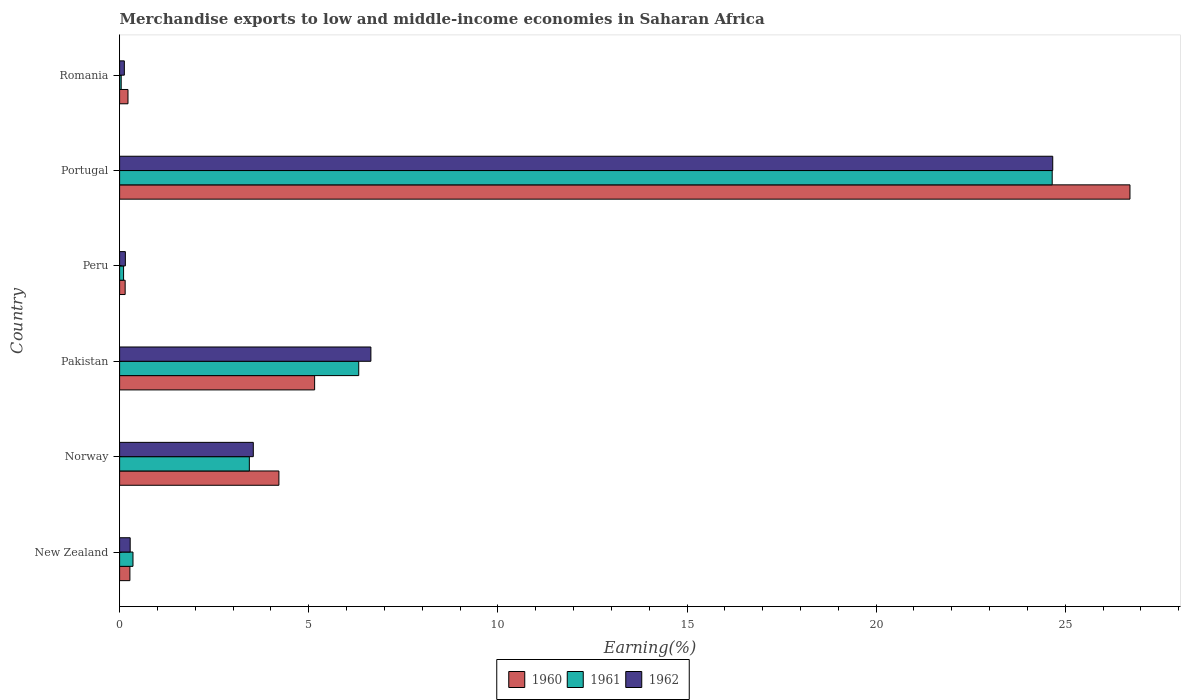How many different coloured bars are there?
Make the answer very short. 3. How many groups of bars are there?
Your answer should be very brief. 6. Are the number of bars per tick equal to the number of legend labels?
Ensure brevity in your answer.  Yes. Are the number of bars on each tick of the Y-axis equal?
Ensure brevity in your answer.  Yes. How many bars are there on the 5th tick from the bottom?
Offer a very short reply. 3. In how many cases, is the number of bars for a given country not equal to the number of legend labels?
Your answer should be very brief. 0. What is the percentage of amount earned from merchandise exports in 1961 in Romania?
Your response must be concise. 0.04. Across all countries, what is the maximum percentage of amount earned from merchandise exports in 1960?
Offer a very short reply. 26.71. Across all countries, what is the minimum percentage of amount earned from merchandise exports in 1960?
Offer a terse response. 0.15. In which country was the percentage of amount earned from merchandise exports in 1960 maximum?
Offer a very short reply. Portugal. In which country was the percentage of amount earned from merchandise exports in 1962 minimum?
Offer a very short reply. Romania. What is the total percentage of amount earned from merchandise exports in 1961 in the graph?
Your response must be concise. 34.91. What is the difference between the percentage of amount earned from merchandise exports in 1962 in Portugal and that in Romania?
Offer a terse response. 24.54. What is the difference between the percentage of amount earned from merchandise exports in 1960 in Peru and the percentage of amount earned from merchandise exports in 1962 in Norway?
Offer a terse response. -3.39. What is the average percentage of amount earned from merchandise exports in 1960 per country?
Your answer should be compact. 6.12. What is the difference between the percentage of amount earned from merchandise exports in 1961 and percentage of amount earned from merchandise exports in 1962 in Peru?
Your response must be concise. -0.05. In how many countries, is the percentage of amount earned from merchandise exports in 1960 greater than 23 %?
Provide a succinct answer. 1. What is the ratio of the percentage of amount earned from merchandise exports in 1960 in New Zealand to that in Portugal?
Make the answer very short. 0.01. Is the percentage of amount earned from merchandise exports in 1960 in New Zealand less than that in Romania?
Your response must be concise. No. What is the difference between the highest and the second highest percentage of amount earned from merchandise exports in 1961?
Make the answer very short. 18.33. What is the difference between the highest and the lowest percentage of amount earned from merchandise exports in 1962?
Ensure brevity in your answer.  24.54. In how many countries, is the percentage of amount earned from merchandise exports in 1961 greater than the average percentage of amount earned from merchandise exports in 1961 taken over all countries?
Your answer should be compact. 2. What does the 3rd bar from the top in Norway represents?
Provide a succinct answer. 1960. Is it the case that in every country, the sum of the percentage of amount earned from merchandise exports in 1962 and percentage of amount earned from merchandise exports in 1960 is greater than the percentage of amount earned from merchandise exports in 1961?
Offer a terse response. Yes. How many bars are there?
Your answer should be very brief. 18. How many countries are there in the graph?
Your response must be concise. 6. Are the values on the major ticks of X-axis written in scientific E-notation?
Keep it short and to the point. No. Does the graph contain grids?
Your response must be concise. No. How many legend labels are there?
Offer a terse response. 3. What is the title of the graph?
Keep it short and to the point. Merchandise exports to low and middle-income economies in Saharan Africa. What is the label or title of the X-axis?
Make the answer very short. Earning(%). What is the label or title of the Y-axis?
Your answer should be very brief. Country. What is the Earning(%) in 1960 in New Zealand?
Provide a succinct answer. 0.27. What is the Earning(%) in 1961 in New Zealand?
Provide a short and direct response. 0.35. What is the Earning(%) of 1962 in New Zealand?
Your answer should be very brief. 0.28. What is the Earning(%) of 1960 in Norway?
Provide a short and direct response. 4.21. What is the Earning(%) in 1961 in Norway?
Keep it short and to the point. 3.43. What is the Earning(%) of 1962 in Norway?
Ensure brevity in your answer.  3.53. What is the Earning(%) in 1960 in Pakistan?
Ensure brevity in your answer.  5.16. What is the Earning(%) of 1961 in Pakistan?
Offer a very short reply. 6.32. What is the Earning(%) of 1962 in Pakistan?
Provide a short and direct response. 6.64. What is the Earning(%) in 1960 in Peru?
Your answer should be compact. 0.15. What is the Earning(%) in 1961 in Peru?
Keep it short and to the point. 0.1. What is the Earning(%) of 1962 in Peru?
Your answer should be very brief. 0.15. What is the Earning(%) in 1960 in Portugal?
Keep it short and to the point. 26.71. What is the Earning(%) of 1961 in Portugal?
Offer a terse response. 24.65. What is the Earning(%) of 1962 in Portugal?
Offer a terse response. 24.67. What is the Earning(%) of 1960 in Romania?
Offer a terse response. 0.22. What is the Earning(%) in 1961 in Romania?
Your answer should be compact. 0.04. What is the Earning(%) in 1962 in Romania?
Keep it short and to the point. 0.13. Across all countries, what is the maximum Earning(%) of 1960?
Your answer should be compact. 26.71. Across all countries, what is the maximum Earning(%) of 1961?
Offer a very short reply. 24.65. Across all countries, what is the maximum Earning(%) in 1962?
Offer a very short reply. 24.67. Across all countries, what is the minimum Earning(%) of 1960?
Your answer should be compact. 0.15. Across all countries, what is the minimum Earning(%) in 1961?
Give a very brief answer. 0.04. Across all countries, what is the minimum Earning(%) in 1962?
Keep it short and to the point. 0.13. What is the total Earning(%) in 1960 in the graph?
Ensure brevity in your answer.  36.72. What is the total Earning(%) of 1961 in the graph?
Offer a terse response. 34.91. What is the total Earning(%) of 1962 in the graph?
Offer a terse response. 35.4. What is the difference between the Earning(%) of 1960 in New Zealand and that in Norway?
Give a very brief answer. -3.94. What is the difference between the Earning(%) in 1961 in New Zealand and that in Norway?
Provide a short and direct response. -3.08. What is the difference between the Earning(%) of 1962 in New Zealand and that in Norway?
Ensure brevity in your answer.  -3.25. What is the difference between the Earning(%) in 1960 in New Zealand and that in Pakistan?
Offer a terse response. -4.88. What is the difference between the Earning(%) of 1961 in New Zealand and that in Pakistan?
Offer a terse response. -5.97. What is the difference between the Earning(%) of 1962 in New Zealand and that in Pakistan?
Offer a terse response. -6.36. What is the difference between the Earning(%) of 1960 in New Zealand and that in Peru?
Your answer should be compact. 0.13. What is the difference between the Earning(%) in 1961 in New Zealand and that in Peru?
Make the answer very short. 0.25. What is the difference between the Earning(%) of 1962 in New Zealand and that in Peru?
Ensure brevity in your answer.  0.13. What is the difference between the Earning(%) in 1960 in New Zealand and that in Portugal?
Ensure brevity in your answer.  -26.44. What is the difference between the Earning(%) of 1961 in New Zealand and that in Portugal?
Your answer should be very brief. -24.3. What is the difference between the Earning(%) of 1962 in New Zealand and that in Portugal?
Your answer should be very brief. -24.39. What is the difference between the Earning(%) of 1960 in New Zealand and that in Romania?
Provide a succinct answer. 0.05. What is the difference between the Earning(%) in 1961 in New Zealand and that in Romania?
Your answer should be very brief. 0.31. What is the difference between the Earning(%) of 1962 in New Zealand and that in Romania?
Provide a succinct answer. 0.15. What is the difference between the Earning(%) in 1960 in Norway and that in Pakistan?
Ensure brevity in your answer.  -0.94. What is the difference between the Earning(%) in 1961 in Norway and that in Pakistan?
Make the answer very short. -2.89. What is the difference between the Earning(%) of 1962 in Norway and that in Pakistan?
Your response must be concise. -3.11. What is the difference between the Earning(%) in 1960 in Norway and that in Peru?
Make the answer very short. 4.06. What is the difference between the Earning(%) in 1961 in Norway and that in Peru?
Provide a succinct answer. 3.32. What is the difference between the Earning(%) in 1962 in Norway and that in Peru?
Your answer should be compact. 3.38. What is the difference between the Earning(%) of 1960 in Norway and that in Portugal?
Ensure brevity in your answer.  -22.5. What is the difference between the Earning(%) in 1961 in Norway and that in Portugal?
Ensure brevity in your answer.  -21.22. What is the difference between the Earning(%) in 1962 in Norway and that in Portugal?
Your response must be concise. -21.13. What is the difference between the Earning(%) in 1960 in Norway and that in Romania?
Ensure brevity in your answer.  3.99. What is the difference between the Earning(%) in 1961 in Norway and that in Romania?
Offer a terse response. 3.39. What is the difference between the Earning(%) of 1962 in Norway and that in Romania?
Ensure brevity in your answer.  3.41. What is the difference between the Earning(%) in 1960 in Pakistan and that in Peru?
Keep it short and to the point. 5.01. What is the difference between the Earning(%) of 1961 in Pakistan and that in Peru?
Provide a succinct answer. 6.22. What is the difference between the Earning(%) of 1962 in Pakistan and that in Peru?
Your response must be concise. 6.49. What is the difference between the Earning(%) in 1960 in Pakistan and that in Portugal?
Ensure brevity in your answer.  -21.55. What is the difference between the Earning(%) in 1961 in Pakistan and that in Portugal?
Your answer should be compact. -18.33. What is the difference between the Earning(%) of 1962 in Pakistan and that in Portugal?
Offer a terse response. -18.03. What is the difference between the Earning(%) in 1960 in Pakistan and that in Romania?
Your response must be concise. 4.93. What is the difference between the Earning(%) of 1961 in Pakistan and that in Romania?
Provide a short and direct response. 6.28. What is the difference between the Earning(%) of 1962 in Pakistan and that in Romania?
Your answer should be compact. 6.52. What is the difference between the Earning(%) of 1960 in Peru and that in Portugal?
Offer a terse response. -26.56. What is the difference between the Earning(%) in 1961 in Peru and that in Portugal?
Provide a succinct answer. -24.55. What is the difference between the Earning(%) in 1962 in Peru and that in Portugal?
Provide a succinct answer. -24.52. What is the difference between the Earning(%) in 1960 in Peru and that in Romania?
Provide a short and direct response. -0.07. What is the difference between the Earning(%) of 1961 in Peru and that in Romania?
Offer a very short reply. 0.06. What is the difference between the Earning(%) of 1962 in Peru and that in Romania?
Offer a very short reply. 0.03. What is the difference between the Earning(%) in 1960 in Portugal and that in Romania?
Your answer should be compact. 26.49. What is the difference between the Earning(%) in 1961 in Portugal and that in Romania?
Keep it short and to the point. 24.61. What is the difference between the Earning(%) of 1962 in Portugal and that in Romania?
Offer a very short reply. 24.54. What is the difference between the Earning(%) in 1960 in New Zealand and the Earning(%) in 1961 in Norway?
Offer a terse response. -3.16. What is the difference between the Earning(%) in 1960 in New Zealand and the Earning(%) in 1962 in Norway?
Your answer should be very brief. -3.26. What is the difference between the Earning(%) in 1961 in New Zealand and the Earning(%) in 1962 in Norway?
Provide a short and direct response. -3.18. What is the difference between the Earning(%) in 1960 in New Zealand and the Earning(%) in 1961 in Pakistan?
Offer a terse response. -6.05. What is the difference between the Earning(%) of 1960 in New Zealand and the Earning(%) of 1962 in Pakistan?
Provide a succinct answer. -6.37. What is the difference between the Earning(%) of 1961 in New Zealand and the Earning(%) of 1962 in Pakistan?
Give a very brief answer. -6.29. What is the difference between the Earning(%) in 1960 in New Zealand and the Earning(%) in 1961 in Peru?
Your response must be concise. 0.17. What is the difference between the Earning(%) in 1960 in New Zealand and the Earning(%) in 1962 in Peru?
Ensure brevity in your answer.  0.12. What is the difference between the Earning(%) in 1961 in New Zealand and the Earning(%) in 1962 in Peru?
Your response must be concise. 0.2. What is the difference between the Earning(%) in 1960 in New Zealand and the Earning(%) in 1961 in Portugal?
Your answer should be compact. -24.38. What is the difference between the Earning(%) in 1960 in New Zealand and the Earning(%) in 1962 in Portugal?
Offer a terse response. -24.4. What is the difference between the Earning(%) in 1961 in New Zealand and the Earning(%) in 1962 in Portugal?
Your answer should be very brief. -24.31. What is the difference between the Earning(%) of 1960 in New Zealand and the Earning(%) of 1961 in Romania?
Provide a succinct answer. 0.23. What is the difference between the Earning(%) in 1960 in New Zealand and the Earning(%) in 1962 in Romania?
Offer a very short reply. 0.15. What is the difference between the Earning(%) of 1961 in New Zealand and the Earning(%) of 1962 in Romania?
Provide a succinct answer. 0.23. What is the difference between the Earning(%) in 1960 in Norway and the Earning(%) in 1961 in Pakistan?
Offer a very short reply. -2.11. What is the difference between the Earning(%) in 1960 in Norway and the Earning(%) in 1962 in Pakistan?
Offer a very short reply. -2.43. What is the difference between the Earning(%) in 1961 in Norway and the Earning(%) in 1962 in Pakistan?
Ensure brevity in your answer.  -3.21. What is the difference between the Earning(%) in 1960 in Norway and the Earning(%) in 1961 in Peru?
Offer a very short reply. 4.11. What is the difference between the Earning(%) of 1960 in Norway and the Earning(%) of 1962 in Peru?
Your answer should be very brief. 4.06. What is the difference between the Earning(%) in 1961 in Norway and the Earning(%) in 1962 in Peru?
Your answer should be very brief. 3.28. What is the difference between the Earning(%) of 1960 in Norway and the Earning(%) of 1961 in Portugal?
Ensure brevity in your answer.  -20.44. What is the difference between the Earning(%) of 1960 in Norway and the Earning(%) of 1962 in Portugal?
Make the answer very short. -20.46. What is the difference between the Earning(%) in 1961 in Norway and the Earning(%) in 1962 in Portugal?
Keep it short and to the point. -21.24. What is the difference between the Earning(%) of 1960 in Norway and the Earning(%) of 1961 in Romania?
Give a very brief answer. 4.17. What is the difference between the Earning(%) of 1960 in Norway and the Earning(%) of 1962 in Romania?
Your response must be concise. 4.09. What is the difference between the Earning(%) of 1961 in Norway and the Earning(%) of 1962 in Romania?
Make the answer very short. 3.3. What is the difference between the Earning(%) in 1960 in Pakistan and the Earning(%) in 1961 in Peru?
Give a very brief answer. 5.05. What is the difference between the Earning(%) in 1960 in Pakistan and the Earning(%) in 1962 in Peru?
Provide a succinct answer. 5. What is the difference between the Earning(%) of 1961 in Pakistan and the Earning(%) of 1962 in Peru?
Offer a very short reply. 6.17. What is the difference between the Earning(%) in 1960 in Pakistan and the Earning(%) in 1961 in Portugal?
Your answer should be compact. -19.5. What is the difference between the Earning(%) of 1960 in Pakistan and the Earning(%) of 1962 in Portugal?
Your answer should be compact. -19.51. What is the difference between the Earning(%) of 1961 in Pakistan and the Earning(%) of 1962 in Portugal?
Keep it short and to the point. -18.35. What is the difference between the Earning(%) in 1960 in Pakistan and the Earning(%) in 1961 in Romania?
Offer a very short reply. 5.11. What is the difference between the Earning(%) in 1960 in Pakistan and the Earning(%) in 1962 in Romania?
Offer a very short reply. 5.03. What is the difference between the Earning(%) of 1961 in Pakistan and the Earning(%) of 1962 in Romania?
Make the answer very short. 6.2. What is the difference between the Earning(%) in 1960 in Peru and the Earning(%) in 1961 in Portugal?
Give a very brief answer. -24.51. What is the difference between the Earning(%) in 1960 in Peru and the Earning(%) in 1962 in Portugal?
Give a very brief answer. -24.52. What is the difference between the Earning(%) in 1961 in Peru and the Earning(%) in 1962 in Portugal?
Offer a very short reply. -24.56. What is the difference between the Earning(%) in 1960 in Peru and the Earning(%) in 1961 in Romania?
Provide a succinct answer. 0.1. What is the difference between the Earning(%) in 1960 in Peru and the Earning(%) in 1962 in Romania?
Make the answer very short. 0.02. What is the difference between the Earning(%) in 1961 in Peru and the Earning(%) in 1962 in Romania?
Offer a terse response. -0.02. What is the difference between the Earning(%) in 1960 in Portugal and the Earning(%) in 1961 in Romania?
Ensure brevity in your answer.  26.67. What is the difference between the Earning(%) of 1960 in Portugal and the Earning(%) of 1962 in Romania?
Make the answer very short. 26.58. What is the difference between the Earning(%) in 1961 in Portugal and the Earning(%) in 1962 in Romania?
Provide a short and direct response. 24.53. What is the average Earning(%) of 1960 per country?
Offer a very short reply. 6.12. What is the average Earning(%) of 1961 per country?
Offer a very short reply. 5.82. What is the average Earning(%) of 1962 per country?
Provide a succinct answer. 5.9. What is the difference between the Earning(%) of 1960 and Earning(%) of 1961 in New Zealand?
Keep it short and to the point. -0.08. What is the difference between the Earning(%) in 1960 and Earning(%) in 1962 in New Zealand?
Give a very brief answer. -0.01. What is the difference between the Earning(%) of 1961 and Earning(%) of 1962 in New Zealand?
Ensure brevity in your answer.  0.07. What is the difference between the Earning(%) in 1960 and Earning(%) in 1961 in Norway?
Provide a succinct answer. 0.78. What is the difference between the Earning(%) of 1960 and Earning(%) of 1962 in Norway?
Give a very brief answer. 0.68. What is the difference between the Earning(%) of 1961 and Earning(%) of 1962 in Norway?
Make the answer very short. -0.1. What is the difference between the Earning(%) of 1960 and Earning(%) of 1961 in Pakistan?
Keep it short and to the point. -1.17. What is the difference between the Earning(%) in 1960 and Earning(%) in 1962 in Pakistan?
Ensure brevity in your answer.  -1.49. What is the difference between the Earning(%) in 1961 and Earning(%) in 1962 in Pakistan?
Make the answer very short. -0.32. What is the difference between the Earning(%) in 1960 and Earning(%) in 1961 in Peru?
Your response must be concise. 0.04. What is the difference between the Earning(%) of 1960 and Earning(%) of 1962 in Peru?
Offer a terse response. -0.01. What is the difference between the Earning(%) of 1961 and Earning(%) of 1962 in Peru?
Give a very brief answer. -0.05. What is the difference between the Earning(%) in 1960 and Earning(%) in 1961 in Portugal?
Keep it short and to the point. 2.06. What is the difference between the Earning(%) in 1960 and Earning(%) in 1962 in Portugal?
Your answer should be compact. 2.04. What is the difference between the Earning(%) of 1961 and Earning(%) of 1962 in Portugal?
Your answer should be very brief. -0.01. What is the difference between the Earning(%) of 1960 and Earning(%) of 1961 in Romania?
Offer a terse response. 0.18. What is the difference between the Earning(%) of 1960 and Earning(%) of 1962 in Romania?
Offer a very short reply. 0.1. What is the difference between the Earning(%) of 1961 and Earning(%) of 1962 in Romania?
Make the answer very short. -0.08. What is the ratio of the Earning(%) in 1960 in New Zealand to that in Norway?
Ensure brevity in your answer.  0.06. What is the ratio of the Earning(%) of 1961 in New Zealand to that in Norway?
Ensure brevity in your answer.  0.1. What is the ratio of the Earning(%) in 1962 in New Zealand to that in Norway?
Provide a succinct answer. 0.08. What is the ratio of the Earning(%) of 1960 in New Zealand to that in Pakistan?
Your answer should be very brief. 0.05. What is the ratio of the Earning(%) in 1961 in New Zealand to that in Pakistan?
Offer a very short reply. 0.06. What is the ratio of the Earning(%) in 1962 in New Zealand to that in Pakistan?
Provide a short and direct response. 0.04. What is the ratio of the Earning(%) in 1960 in New Zealand to that in Peru?
Make the answer very short. 1.85. What is the ratio of the Earning(%) of 1961 in New Zealand to that in Peru?
Offer a terse response. 3.37. What is the ratio of the Earning(%) of 1962 in New Zealand to that in Peru?
Provide a short and direct response. 1.84. What is the ratio of the Earning(%) in 1960 in New Zealand to that in Portugal?
Provide a short and direct response. 0.01. What is the ratio of the Earning(%) in 1961 in New Zealand to that in Portugal?
Offer a terse response. 0.01. What is the ratio of the Earning(%) in 1962 in New Zealand to that in Portugal?
Make the answer very short. 0.01. What is the ratio of the Earning(%) in 1960 in New Zealand to that in Romania?
Keep it short and to the point. 1.23. What is the ratio of the Earning(%) in 1961 in New Zealand to that in Romania?
Provide a short and direct response. 8.45. What is the ratio of the Earning(%) in 1962 in New Zealand to that in Romania?
Your response must be concise. 2.23. What is the ratio of the Earning(%) in 1960 in Norway to that in Pakistan?
Ensure brevity in your answer.  0.82. What is the ratio of the Earning(%) in 1961 in Norway to that in Pakistan?
Your response must be concise. 0.54. What is the ratio of the Earning(%) in 1962 in Norway to that in Pakistan?
Keep it short and to the point. 0.53. What is the ratio of the Earning(%) of 1960 in Norway to that in Peru?
Make the answer very short. 28.69. What is the ratio of the Earning(%) of 1961 in Norway to that in Peru?
Ensure brevity in your answer.  32.67. What is the ratio of the Earning(%) in 1962 in Norway to that in Peru?
Provide a succinct answer. 23.23. What is the ratio of the Earning(%) in 1960 in Norway to that in Portugal?
Ensure brevity in your answer.  0.16. What is the ratio of the Earning(%) of 1961 in Norway to that in Portugal?
Offer a terse response. 0.14. What is the ratio of the Earning(%) of 1962 in Norway to that in Portugal?
Your response must be concise. 0.14. What is the ratio of the Earning(%) in 1960 in Norway to that in Romania?
Give a very brief answer. 19. What is the ratio of the Earning(%) in 1961 in Norway to that in Romania?
Keep it short and to the point. 81.93. What is the ratio of the Earning(%) of 1962 in Norway to that in Romania?
Your answer should be very brief. 28.18. What is the ratio of the Earning(%) in 1960 in Pakistan to that in Peru?
Provide a short and direct response. 35.13. What is the ratio of the Earning(%) in 1961 in Pakistan to that in Peru?
Provide a short and direct response. 60.22. What is the ratio of the Earning(%) of 1962 in Pakistan to that in Peru?
Offer a terse response. 43.66. What is the ratio of the Earning(%) of 1960 in Pakistan to that in Portugal?
Your answer should be very brief. 0.19. What is the ratio of the Earning(%) in 1961 in Pakistan to that in Portugal?
Your answer should be very brief. 0.26. What is the ratio of the Earning(%) of 1962 in Pakistan to that in Portugal?
Keep it short and to the point. 0.27. What is the ratio of the Earning(%) of 1960 in Pakistan to that in Romania?
Offer a terse response. 23.26. What is the ratio of the Earning(%) in 1961 in Pakistan to that in Romania?
Provide a succinct answer. 151. What is the ratio of the Earning(%) of 1962 in Pakistan to that in Romania?
Provide a succinct answer. 52.96. What is the ratio of the Earning(%) in 1960 in Peru to that in Portugal?
Give a very brief answer. 0.01. What is the ratio of the Earning(%) in 1961 in Peru to that in Portugal?
Keep it short and to the point. 0. What is the ratio of the Earning(%) of 1962 in Peru to that in Portugal?
Provide a succinct answer. 0.01. What is the ratio of the Earning(%) in 1960 in Peru to that in Romania?
Keep it short and to the point. 0.66. What is the ratio of the Earning(%) in 1961 in Peru to that in Romania?
Make the answer very short. 2.51. What is the ratio of the Earning(%) of 1962 in Peru to that in Romania?
Offer a terse response. 1.21. What is the ratio of the Earning(%) in 1960 in Portugal to that in Romania?
Ensure brevity in your answer.  120.48. What is the ratio of the Earning(%) in 1961 in Portugal to that in Romania?
Your answer should be very brief. 588.91. What is the ratio of the Earning(%) of 1962 in Portugal to that in Romania?
Offer a terse response. 196.67. What is the difference between the highest and the second highest Earning(%) in 1960?
Offer a terse response. 21.55. What is the difference between the highest and the second highest Earning(%) of 1961?
Keep it short and to the point. 18.33. What is the difference between the highest and the second highest Earning(%) of 1962?
Your response must be concise. 18.03. What is the difference between the highest and the lowest Earning(%) in 1960?
Your answer should be compact. 26.56. What is the difference between the highest and the lowest Earning(%) of 1961?
Make the answer very short. 24.61. What is the difference between the highest and the lowest Earning(%) in 1962?
Ensure brevity in your answer.  24.54. 